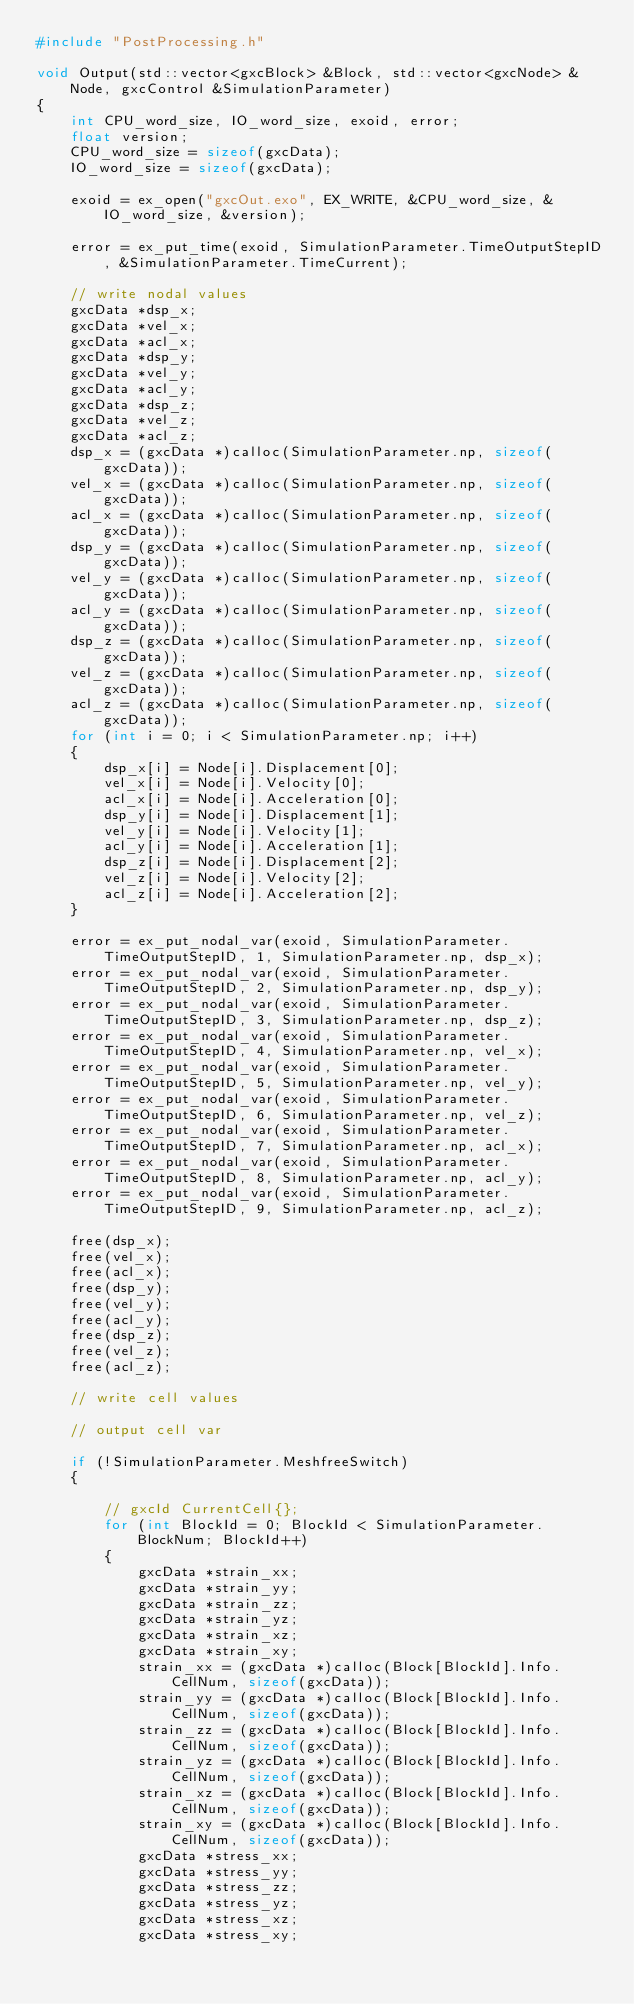<code> <loc_0><loc_0><loc_500><loc_500><_C++_>#include "PostProcessing.h"

void Output(std::vector<gxcBlock> &Block, std::vector<gxcNode> &Node, gxcControl &SimulationParameter)
{
    int CPU_word_size, IO_word_size, exoid, error;
    float version;
    CPU_word_size = sizeof(gxcData);
    IO_word_size = sizeof(gxcData);

    exoid = ex_open("gxcOut.exo", EX_WRITE, &CPU_word_size, &IO_word_size, &version);
    
    error = ex_put_time(exoid, SimulationParameter.TimeOutputStepID, &SimulationParameter.TimeCurrent);

    // write nodal values
    gxcData *dsp_x;
    gxcData *vel_x;
    gxcData *acl_x;
    gxcData *dsp_y;
    gxcData *vel_y;
    gxcData *acl_y;
    gxcData *dsp_z;
    gxcData *vel_z;
    gxcData *acl_z;
    dsp_x = (gxcData *)calloc(SimulationParameter.np, sizeof(gxcData));
    vel_x = (gxcData *)calloc(SimulationParameter.np, sizeof(gxcData));
    acl_x = (gxcData *)calloc(SimulationParameter.np, sizeof(gxcData));
    dsp_y = (gxcData *)calloc(SimulationParameter.np, sizeof(gxcData));
    vel_y = (gxcData *)calloc(SimulationParameter.np, sizeof(gxcData));
    acl_y = (gxcData *)calloc(SimulationParameter.np, sizeof(gxcData));
    dsp_z = (gxcData *)calloc(SimulationParameter.np, sizeof(gxcData));
    vel_z = (gxcData *)calloc(SimulationParameter.np, sizeof(gxcData));
    acl_z = (gxcData *)calloc(SimulationParameter.np, sizeof(gxcData));
    for (int i = 0; i < SimulationParameter.np; i++)
    {
        dsp_x[i] = Node[i].Displacement[0];
        vel_x[i] = Node[i].Velocity[0];
        acl_x[i] = Node[i].Acceleration[0];
        dsp_y[i] = Node[i].Displacement[1];
        vel_y[i] = Node[i].Velocity[1];
        acl_y[i] = Node[i].Acceleration[1];
        dsp_z[i] = Node[i].Displacement[2];
        vel_z[i] = Node[i].Velocity[2];
        acl_z[i] = Node[i].Acceleration[2];
    }

    error = ex_put_nodal_var(exoid, SimulationParameter.TimeOutputStepID, 1, SimulationParameter.np, dsp_x);
    error = ex_put_nodal_var(exoid, SimulationParameter.TimeOutputStepID, 2, SimulationParameter.np, dsp_y);
    error = ex_put_nodal_var(exoid, SimulationParameter.TimeOutputStepID, 3, SimulationParameter.np, dsp_z);
    error = ex_put_nodal_var(exoid, SimulationParameter.TimeOutputStepID, 4, SimulationParameter.np, vel_x);
    error = ex_put_nodal_var(exoid, SimulationParameter.TimeOutputStepID, 5, SimulationParameter.np, vel_y);
    error = ex_put_nodal_var(exoid, SimulationParameter.TimeOutputStepID, 6, SimulationParameter.np, vel_z);
    error = ex_put_nodal_var(exoid, SimulationParameter.TimeOutputStepID, 7, SimulationParameter.np, acl_x);
    error = ex_put_nodal_var(exoid, SimulationParameter.TimeOutputStepID, 8, SimulationParameter.np, acl_y);
    error = ex_put_nodal_var(exoid, SimulationParameter.TimeOutputStepID, 9, SimulationParameter.np, acl_z);

    free(dsp_x);
    free(vel_x);
    free(acl_x);
    free(dsp_y);
    free(vel_y);
    free(acl_y);
    free(dsp_z);
    free(vel_z);
    free(acl_z);

    // write cell values

    // output cell var

    if (!SimulationParameter.MeshfreeSwitch)
    {

        // gxcId CurrentCell{};
        for (int BlockId = 0; BlockId < SimulationParameter.BlockNum; BlockId++)
        {
            gxcData *strain_xx;
            gxcData *strain_yy;
            gxcData *strain_zz;
            gxcData *strain_yz;
            gxcData *strain_xz;
            gxcData *strain_xy;
            strain_xx = (gxcData *)calloc(Block[BlockId].Info.CellNum, sizeof(gxcData));
            strain_yy = (gxcData *)calloc(Block[BlockId].Info.CellNum, sizeof(gxcData));
            strain_zz = (gxcData *)calloc(Block[BlockId].Info.CellNum, sizeof(gxcData));
            strain_yz = (gxcData *)calloc(Block[BlockId].Info.CellNum, sizeof(gxcData));
            strain_xz = (gxcData *)calloc(Block[BlockId].Info.CellNum, sizeof(gxcData));
            strain_xy = (gxcData *)calloc(Block[BlockId].Info.CellNum, sizeof(gxcData));
            gxcData *stress_xx;
            gxcData *stress_yy;
            gxcData *stress_zz;
            gxcData *stress_yz;
            gxcData *stress_xz;
            gxcData *stress_xy;</code> 